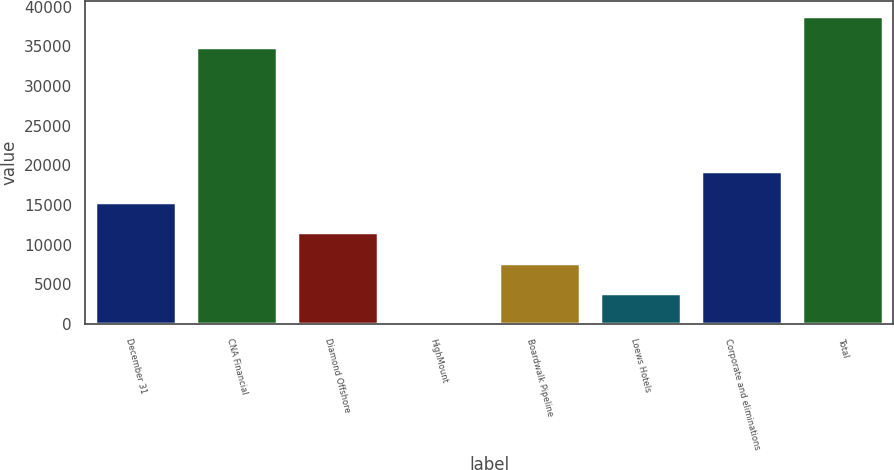<chart> <loc_0><loc_0><loc_500><loc_500><bar_chart><fcel>December 31<fcel>CNA Financial<fcel>Diamond Offshore<fcel>HighMount<fcel>Boardwalk Pipeline<fcel>Loews Hotels<fcel>Corporate and eliminations<fcel>Total<nl><fcel>15407.6<fcel>34980<fcel>11567.2<fcel>46<fcel>7726.8<fcel>3886.4<fcel>19248<fcel>38820.4<nl></chart> 